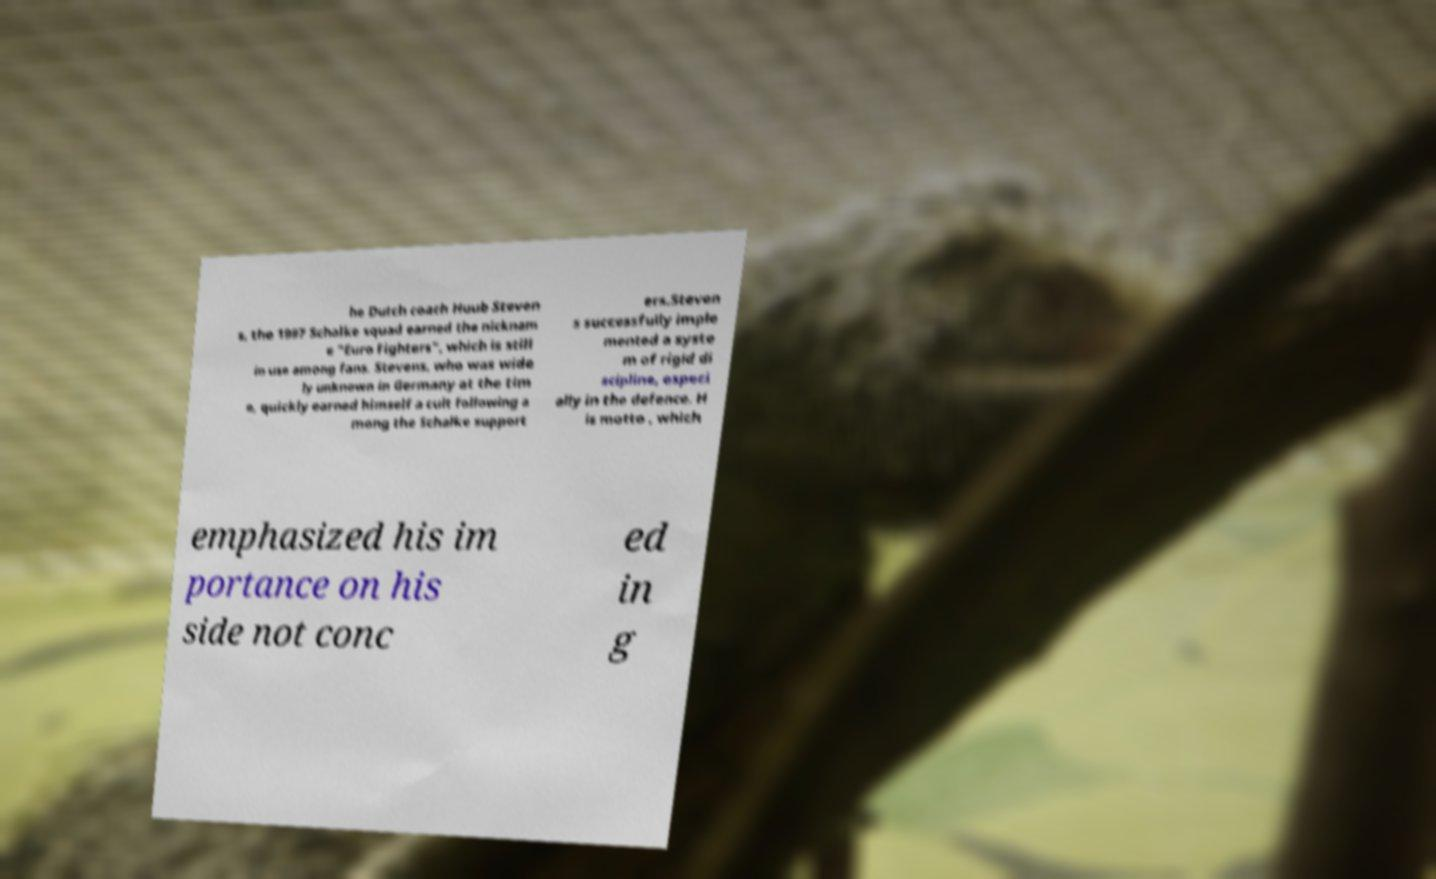Can you read and provide the text displayed in the image?This photo seems to have some interesting text. Can you extract and type it out for me? he Dutch coach Huub Steven s, the 1997 Schalke squad earned the nicknam e "Euro Fighters", which is still in use among fans. Stevens, who was wide ly unknown in Germany at the tim e, quickly earned himself a cult following a mong the Schalke support ers.Steven s successfully imple mented a syste m of rigid di scipline, especi ally in the defence. H is motto , which emphasized his im portance on his side not conc ed in g 